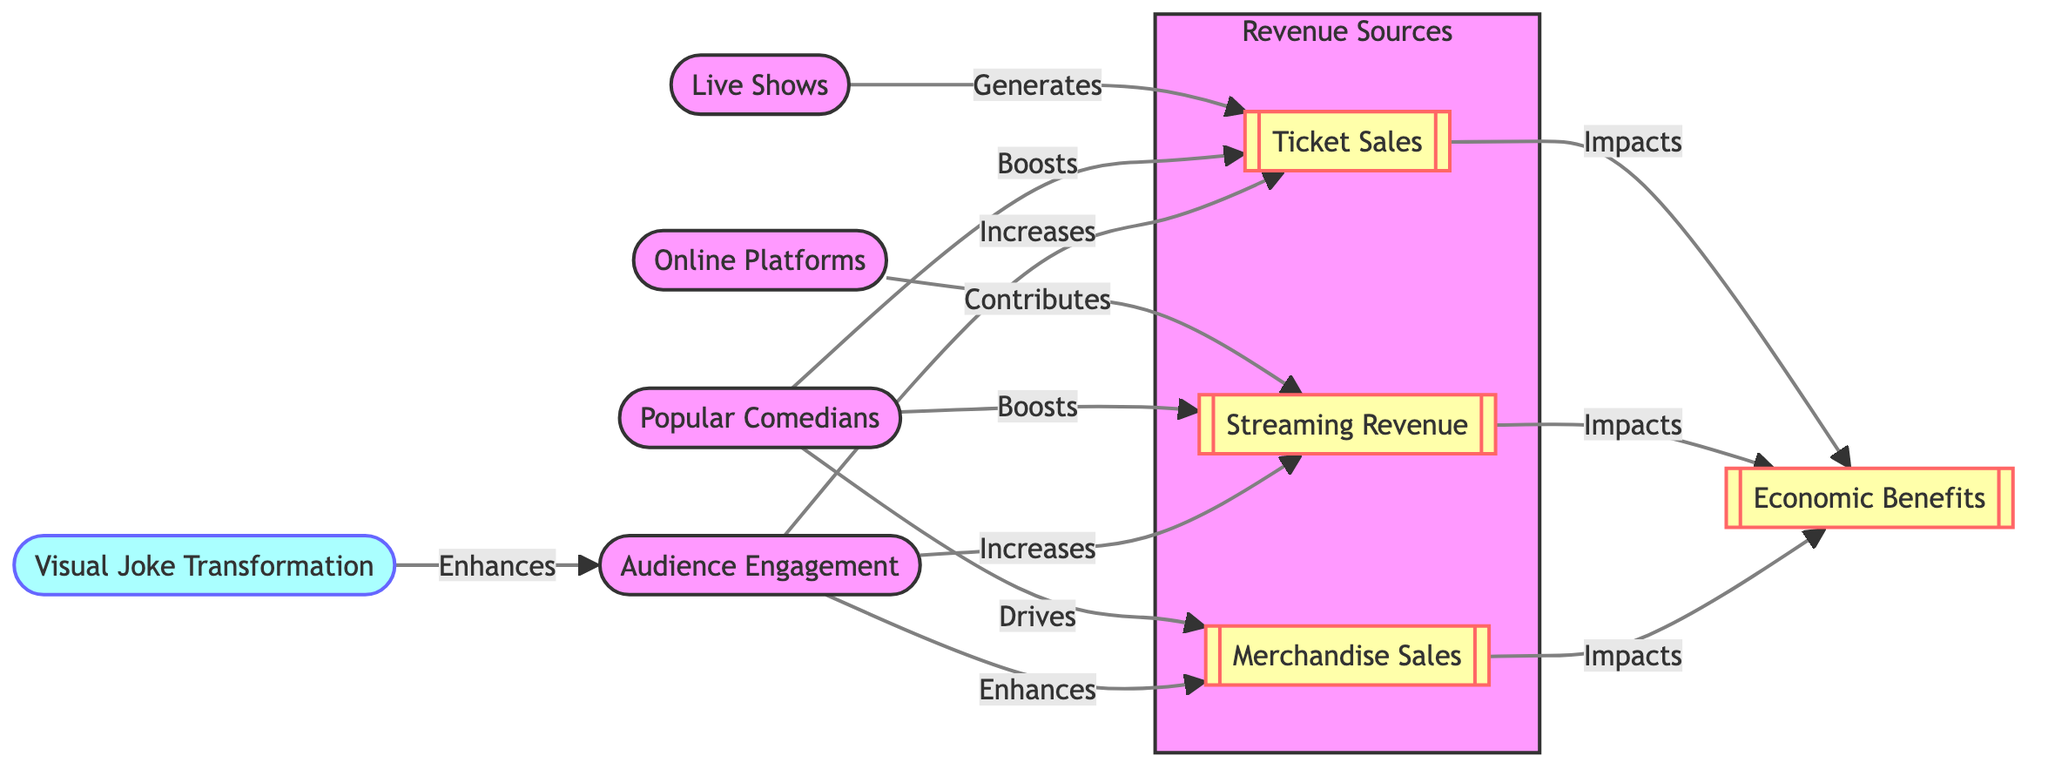What are the three revenue sources identified in the diagram? The diagram lists three revenue sources: Ticket Sales, Streaming Revenue, and Merchandise Sales as part of the Revenue Sources subgraph.
Answer: Ticket Sales, Streaming Revenue, Merchandise Sales Which node contributes to streaming revenue? According to the diagram, Online Platforms contribute to Streaming Revenue, as indicated by the directed arrow between these two nodes.
Answer: Online Platforms How many nodes are there for economic benefits in the diagram? There is only one node labeled Economic Benefits that accumulates the impact of Ticket Sales, Streaming Revenue, and Merchandise Sales.
Answer: One What increases both ticket sales and streaming revenue? The diagram shows that Audience Engagement increases both Ticket Sales and Streaming Revenue, demonstrated by the connecting arrows leading to both nodes.
Answer: Audience Engagement Which element enhances audience engagement? The diagram states that Visual Joke Transformation enhances Audience Engagement, as represented by the directed arrow pointing from the Visual Joke Transformation node to the Audience Engagement node.
Answer: Visual Joke Transformation Which two factors drive merchandise sales? The diagram indicates that both Popular Comedians and Audience Engagement drive Merchandise Sales through directed arrows connecting them to the Merchandise Sales node.
Answer: Popular Comedians, Audience Engagement How does ticket sales impact economic benefits? The diagram illustrates that Ticket Sales directly impacts Economic Benefits, as depicted by the arrow flowing from the Ticket Sales node to the Economic Benefits node.
Answer: Impacts Name a source that generates ticket sales. Live Shows are noted in the diagram as generating Ticket Sales, which is represented by the arrow pointing from the Live Shows node to the Ticket Sales node.
Answer: Live Shows 